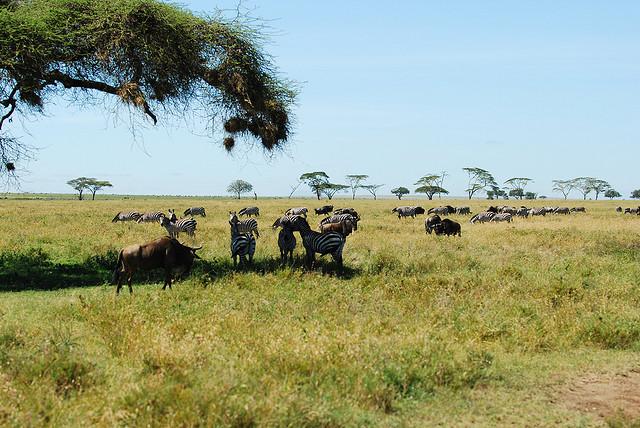Are there more than a dozen sheep here?
Write a very short answer. No. What kind of animal has stripes?
Answer briefly. Zebra. What kind of animals are these?
Keep it brief. Zebras. What species of animal is in the photo?
Write a very short answer. Zebra. Is this in Africa?
Keep it brief. Yes. How many different species are in this picture?
Be succinct. 2. 